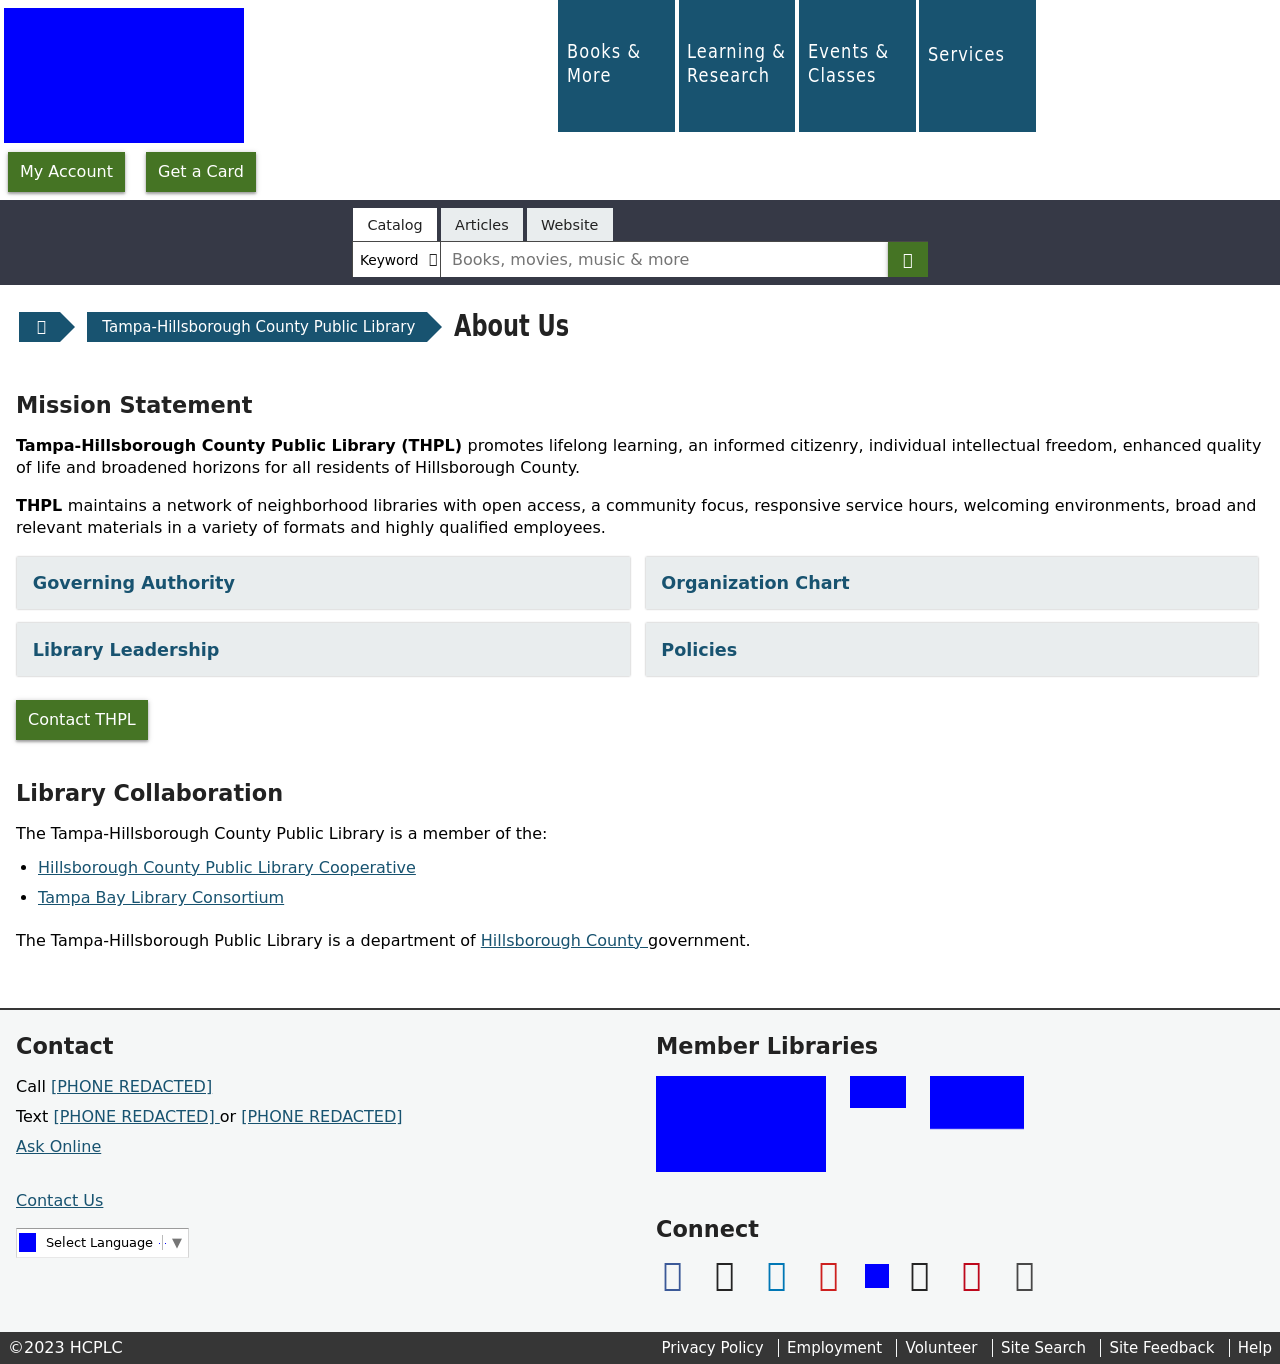Why does the library have a section called 'Mission Statement' prominently displayed on the website? The 'Mission Statement' section is prominently displayed to communicate the library's fundamental goals and values to its visitors. It helps in setting a clear direction for the library's services and is a commitment to its patrons, ensuring that they understand the library’s dedication to promoting lifelong learning, enhancing quality of life, and supporting an informed citizenry.  What purpose does the footer serve on a library website like this? The footer on a library website typically includes important links to contact information, social media channels, policies, and accessibility resources. It serves as a navigation aid, offering easy access to essential information irrespective of where the user is on the website. It also often includes copyright information to protect the site’s content and ensure proper usage rights. 